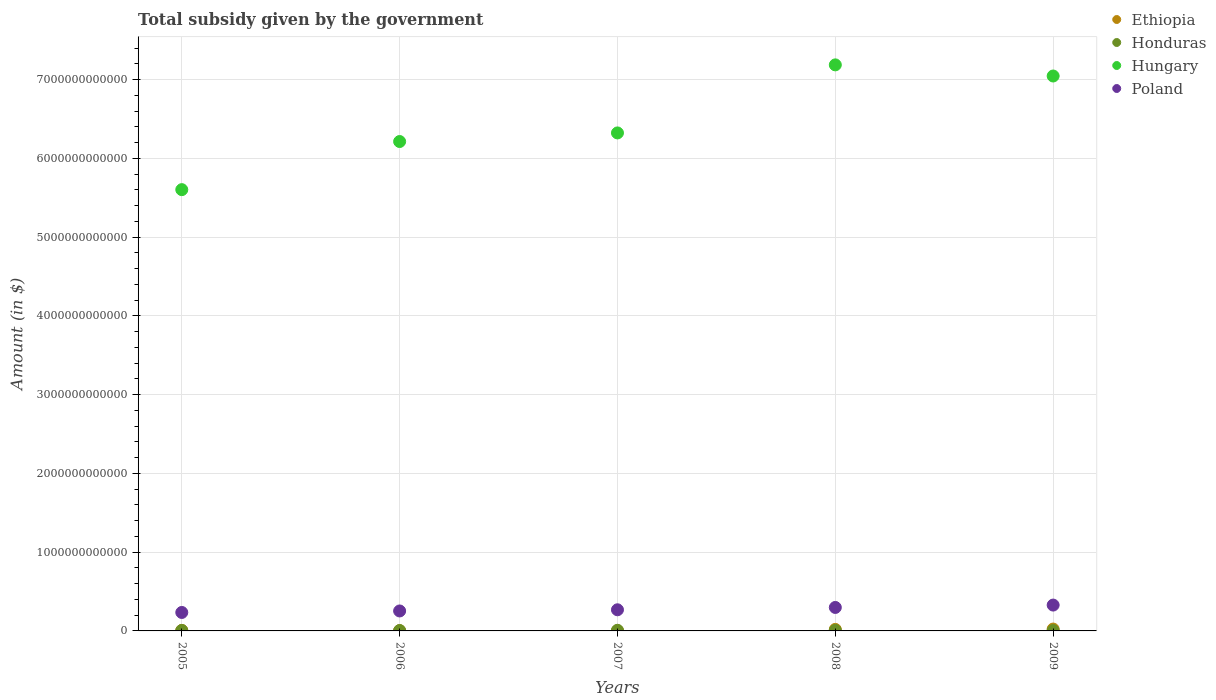How many different coloured dotlines are there?
Offer a very short reply. 4. What is the total revenue collected by the government in Hungary in 2007?
Ensure brevity in your answer.  6.32e+12. Across all years, what is the maximum total revenue collected by the government in Ethiopia?
Ensure brevity in your answer.  2.37e+1. Across all years, what is the minimum total revenue collected by the government in Ethiopia?
Offer a terse response. 1.15e+09. In which year was the total revenue collected by the government in Poland maximum?
Offer a terse response. 2009. What is the total total revenue collected by the government in Honduras in the graph?
Your answer should be compact. 3.04e+1. What is the difference between the total revenue collected by the government in Honduras in 2005 and that in 2009?
Keep it short and to the point. 5.14e+08. What is the difference between the total revenue collected by the government in Ethiopia in 2005 and the total revenue collected by the government in Poland in 2007?
Your response must be concise. -2.62e+11. What is the average total revenue collected by the government in Honduras per year?
Provide a short and direct response. 6.07e+09. In the year 2005, what is the difference between the total revenue collected by the government in Hungary and total revenue collected by the government in Poland?
Your answer should be very brief. 5.37e+12. What is the ratio of the total revenue collected by the government in Poland in 2006 to that in 2009?
Keep it short and to the point. 0.77. What is the difference between the highest and the second highest total revenue collected by the government in Honduras?
Keep it short and to the point. 7.53e+08. What is the difference between the highest and the lowest total revenue collected by the government in Ethiopia?
Provide a short and direct response. 2.26e+1. In how many years, is the total revenue collected by the government in Ethiopia greater than the average total revenue collected by the government in Ethiopia taken over all years?
Give a very brief answer. 2. Does the total revenue collected by the government in Poland monotonically increase over the years?
Ensure brevity in your answer.  Yes. Is the total revenue collected by the government in Poland strictly less than the total revenue collected by the government in Hungary over the years?
Keep it short and to the point. Yes. What is the difference between two consecutive major ticks on the Y-axis?
Offer a terse response. 1.00e+12. Are the values on the major ticks of Y-axis written in scientific E-notation?
Offer a very short reply. No. Does the graph contain any zero values?
Provide a short and direct response. No. Does the graph contain grids?
Your answer should be compact. Yes. What is the title of the graph?
Your answer should be very brief. Total subsidy given by the government. What is the label or title of the X-axis?
Provide a succinct answer. Years. What is the label or title of the Y-axis?
Offer a terse response. Amount (in $). What is the Amount (in $) in Ethiopia in 2005?
Ensure brevity in your answer.  6.65e+09. What is the Amount (in $) of Honduras in 2005?
Offer a very short reply. 5.27e+09. What is the Amount (in $) in Hungary in 2005?
Provide a succinct answer. 5.60e+12. What is the Amount (in $) in Poland in 2005?
Provide a succinct answer. 2.34e+11. What is the Amount (in $) in Ethiopia in 2006?
Make the answer very short. 3.18e+09. What is the Amount (in $) in Honduras in 2006?
Provide a succinct answer. 4.83e+09. What is the Amount (in $) in Hungary in 2006?
Offer a terse response. 6.21e+12. What is the Amount (in $) of Poland in 2006?
Make the answer very short. 2.53e+11. What is the Amount (in $) of Ethiopia in 2007?
Provide a succinct answer. 1.15e+09. What is the Amount (in $) in Honduras in 2007?
Your answer should be compact. 8.13e+09. What is the Amount (in $) in Hungary in 2007?
Keep it short and to the point. 6.32e+12. What is the Amount (in $) in Poland in 2007?
Ensure brevity in your answer.  2.68e+11. What is the Amount (in $) of Ethiopia in 2008?
Provide a short and direct response. 1.94e+1. What is the Amount (in $) of Honduras in 2008?
Your answer should be very brief. 7.38e+09. What is the Amount (in $) of Hungary in 2008?
Make the answer very short. 7.19e+12. What is the Amount (in $) in Poland in 2008?
Make the answer very short. 2.98e+11. What is the Amount (in $) in Ethiopia in 2009?
Your response must be concise. 2.37e+1. What is the Amount (in $) of Honduras in 2009?
Make the answer very short. 4.75e+09. What is the Amount (in $) in Hungary in 2009?
Make the answer very short. 7.04e+12. What is the Amount (in $) of Poland in 2009?
Your response must be concise. 3.28e+11. Across all years, what is the maximum Amount (in $) in Ethiopia?
Your answer should be compact. 2.37e+1. Across all years, what is the maximum Amount (in $) of Honduras?
Offer a very short reply. 8.13e+09. Across all years, what is the maximum Amount (in $) of Hungary?
Provide a succinct answer. 7.19e+12. Across all years, what is the maximum Amount (in $) in Poland?
Your answer should be compact. 3.28e+11. Across all years, what is the minimum Amount (in $) in Ethiopia?
Offer a very short reply. 1.15e+09. Across all years, what is the minimum Amount (in $) in Honduras?
Make the answer very short. 4.75e+09. Across all years, what is the minimum Amount (in $) in Hungary?
Keep it short and to the point. 5.60e+12. Across all years, what is the minimum Amount (in $) in Poland?
Provide a succinct answer. 2.34e+11. What is the total Amount (in $) in Ethiopia in the graph?
Your answer should be compact. 5.41e+1. What is the total Amount (in $) of Honduras in the graph?
Keep it short and to the point. 3.04e+1. What is the total Amount (in $) in Hungary in the graph?
Your answer should be very brief. 3.24e+13. What is the total Amount (in $) in Poland in the graph?
Your answer should be compact. 1.38e+12. What is the difference between the Amount (in $) in Ethiopia in 2005 and that in 2006?
Offer a terse response. 3.48e+09. What is the difference between the Amount (in $) of Honduras in 2005 and that in 2006?
Offer a terse response. 4.33e+08. What is the difference between the Amount (in $) in Hungary in 2005 and that in 2006?
Your answer should be very brief. -6.11e+11. What is the difference between the Amount (in $) in Poland in 2005 and that in 2006?
Your answer should be compact. -1.90e+1. What is the difference between the Amount (in $) in Ethiopia in 2005 and that in 2007?
Keep it short and to the point. 5.51e+09. What is the difference between the Amount (in $) of Honduras in 2005 and that in 2007?
Your answer should be compact. -2.87e+09. What is the difference between the Amount (in $) in Hungary in 2005 and that in 2007?
Provide a short and direct response. -7.20e+11. What is the difference between the Amount (in $) of Poland in 2005 and that in 2007?
Your response must be concise. -3.40e+1. What is the difference between the Amount (in $) in Ethiopia in 2005 and that in 2008?
Your response must be concise. -1.27e+1. What is the difference between the Amount (in $) in Honduras in 2005 and that in 2008?
Ensure brevity in your answer.  -2.11e+09. What is the difference between the Amount (in $) in Hungary in 2005 and that in 2008?
Your response must be concise. -1.58e+12. What is the difference between the Amount (in $) of Poland in 2005 and that in 2008?
Keep it short and to the point. -6.36e+1. What is the difference between the Amount (in $) of Ethiopia in 2005 and that in 2009?
Offer a very short reply. -1.71e+1. What is the difference between the Amount (in $) of Honduras in 2005 and that in 2009?
Your answer should be compact. 5.14e+08. What is the difference between the Amount (in $) of Hungary in 2005 and that in 2009?
Give a very brief answer. -1.44e+12. What is the difference between the Amount (in $) in Poland in 2005 and that in 2009?
Your answer should be compact. -9.38e+1. What is the difference between the Amount (in $) in Ethiopia in 2006 and that in 2007?
Your response must be concise. 2.03e+09. What is the difference between the Amount (in $) of Honduras in 2006 and that in 2007?
Give a very brief answer. -3.30e+09. What is the difference between the Amount (in $) of Hungary in 2006 and that in 2007?
Ensure brevity in your answer.  -1.09e+11. What is the difference between the Amount (in $) in Poland in 2006 and that in 2007?
Give a very brief answer. -1.49e+1. What is the difference between the Amount (in $) of Ethiopia in 2006 and that in 2008?
Make the answer very short. -1.62e+1. What is the difference between the Amount (in $) of Honduras in 2006 and that in 2008?
Offer a very short reply. -2.55e+09. What is the difference between the Amount (in $) of Hungary in 2006 and that in 2008?
Keep it short and to the point. -9.73e+11. What is the difference between the Amount (in $) of Poland in 2006 and that in 2008?
Offer a terse response. -4.45e+1. What is the difference between the Amount (in $) in Ethiopia in 2006 and that in 2009?
Offer a very short reply. -2.05e+1. What is the difference between the Amount (in $) of Honduras in 2006 and that in 2009?
Offer a very short reply. 8.13e+07. What is the difference between the Amount (in $) of Hungary in 2006 and that in 2009?
Provide a short and direct response. -8.32e+11. What is the difference between the Amount (in $) in Poland in 2006 and that in 2009?
Your answer should be very brief. -7.47e+1. What is the difference between the Amount (in $) in Ethiopia in 2007 and that in 2008?
Provide a succinct answer. -1.82e+1. What is the difference between the Amount (in $) of Honduras in 2007 and that in 2008?
Your answer should be compact. 7.53e+08. What is the difference between the Amount (in $) of Hungary in 2007 and that in 2008?
Your response must be concise. -8.64e+11. What is the difference between the Amount (in $) in Poland in 2007 and that in 2008?
Your answer should be very brief. -2.96e+1. What is the difference between the Amount (in $) of Ethiopia in 2007 and that in 2009?
Make the answer very short. -2.26e+1. What is the difference between the Amount (in $) in Honduras in 2007 and that in 2009?
Keep it short and to the point. 3.38e+09. What is the difference between the Amount (in $) in Hungary in 2007 and that in 2009?
Your answer should be very brief. -7.23e+11. What is the difference between the Amount (in $) in Poland in 2007 and that in 2009?
Offer a very short reply. -5.98e+1. What is the difference between the Amount (in $) in Ethiopia in 2008 and that in 2009?
Offer a very short reply. -4.33e+09. What is the difference between the Amount (in $) in Honduras in 2008 and that in 2009?
Provide a succinct answer. 2.63e+09. What is the difference between the Amount (in $) in Hungary in 2008 and that in 2009?
Your response must be concise. 1.41e+11. What is the difference between the Amount (in $) in Poland in 2008 and that in 2009?
Offer a terse response. -3.02e+1. What is the difference between the Amount (in $) of Ethiopia in 2005 and the Amount (in $) of Honduras in 2006?
Your response must be concise. 1.82e+09. What is the difference between the Amount (in $) in Ethiopia in 2005 and the Amount (in $) in Hungary in 2006?
Ensure brevity in your answer.  -6.21e+12. What is the difference between the Amount (in $) of Ethiopia in 2005 and the Amount (in $) of Poland in 2006?
Provide a short and direct response. -2.47e+11. What is the difference between the Amount (in $) of Honduras in 2005 and the Amount (in $) of Hungary in 2006?
Offer a terse response. -6.21e+12. What is the difference between the Amount (in $) of Honduras in 2005 and the Amount (in $) of Poland in 2006?
Keep it short and to the point. -2.48e+11. What is the difference between the Amount (in $) of Hungary in 2005 and the Amount (in $) of Poland in 2006?
Your answer should be very brief. 5.35e+12. What is the difference between the Amount (in $) of Ethiopia in 2005 and the Amount (in $) of Honduras in 2007?
Offer a terse response. -1.48e+09. What is the difference between the Amount (in $) in Ethiopia in 2005 and the Amount (in $) in Hungary in 2007?
Offer a very short reply. -6.32e+12. What is the difference between the Amount (in $) of Ethiopia in 2005 and the Amount (in $) of Poland in 2007?
Keep it short and to the point. -2.62e+11. What is the difference between the Amount (in $) of Honduras in 2005 and the Amount (in $) of Hungary in 2007?
Make the answer very short. -6.32e+12. What is the difference between the Amount (in $) of Honduras in 2005 and the Amount (in $) of Poland in 2007?
Ensure brevity in your answer.  -2.63e+11. What is the difference between the Amount (in $) of Hungary in 2005 and the Amount (in $) of Poland in 2007?
Your answer should be compact. 5.33e+12. What is the difference between the Amount (in $) in Ethiopia in 2005 and the Amount (in $) in Honduras in 2008?
Give a very brief answer. -7.26e+08. What is the difference between the Amount (in $) in Ethiopia in 2005 and the Amount (in $) in Hungary in 2008?
Ensure brevity in your answer.  -7.18e+12. What is the difference between the Amount (in $) in Ethiopia in 2005 and the Amount (in $) in Poland in 2008?
Your answer should be compact. -2.91e+11. What is the difference between the Amount (in $) in Honduras in 2005 and the Amount (in $) in Hungary in 2008?
Your response must be concise. -7.18e+12. What is the difference between the Amount (in $) in Honduras in 2005 and the Amount (in $) in Poland in 2008?
Give a very brief answer. -2.93e+11. What is the difference between the Amount (in $) of Hungary in 2005 and the Amount (in $) of Poland in 2008?
Give a very brief answer. 5.30e+12. What is the difference between the Amount (in $) in Ethiopia in 2005 and the Amount (in $) in Honduras in 2009?
Make the answer very short. 1.90e+09. What is the difference between the Amount (in $) of Ethiopia in 2005 and the Amount (in $) of Hungary in 2009?
Make the answer very short. -7.04e+12. What is the difference between the Amount (in $) in Ethiopia in 2005 and the Amount (in $) in Poland in 2009?
Keep it short and to the point. -3.21e+11. What is the difference between the Amount (in $) in Honduras in 2005 and the Amount (in $) in Hungary in 2009?
Ensure brevity in your answer.  -7.04e+12. What is the difference between the Amount (in $) in Honduras in 2005 and the Amount (in $) in Poland in 2009?
Ensure brevity in your answer.  -3.23e+11. What is the difference between the Amount (in $) in Hungary in 2005 and the Amount (in $) in Poland in 2009?
Your answer should be very brief. 5.27e+12. What is the difference between the Amount (in $) of Ethiopia in 2006 and the Amount (in $) of Honduras in 2007?
Ensure brevity in your answer.  -4.96e+09. What is the difference between the Amount (in $) of Ethiopia in 2006 and the Amount (in $) of Hungary in 2007?
Offer a terse response. -6.32e+12. What is the difference between the Amount (in $) in Ethiopia in 2006 and the Amount (in $) in Poland in 2007?
Make the answer very short. -2.65e+11. What is the difference between the Amount (in $) in Honduras in 2006 and the Amount (in $) in Hungary in 2007?
Provide a short and direct response. -6.32e+12. What is the difference between the Amount (in $) of Honduras in 2006 and the Amount (in $) of Poland in 2007?
Give a very brief answer. -2.64e+11. What is the difference between the Amount (in $) of Hungary in 2006 and the Amount (in $) of Poland in 2007?
Your response must be concise. 5.94e+12. What is the difference between the Amount (in $) of Ethiopia in 2006 and the Amount (in $) of Honduras in 2008?
Your answer should be very brief. -4.20e+09. What is the difference between the Amount (in $) in Ethiopia in 2006 and the Amount (in $) in Hungary in 2008?
Give a very brief answer. -7.18e+12. What is the difference between the Amount (in $) in Ethiopia in 2006 and the Amount (in $) in Poland in 2008?
Provide a short and direct response. -2.95e+11. What is the difference between the Amount (in $) in Honduras in 2006 and the Amount (in $) in Hungary in 2008?
Offer a terse response. -7.18e+12. What is the difference between the Amount (in $) in Honduras in 2006 and the Amount (in $) in Poland in 2008?
Offer a terse response. -2.93e+11. What is the difference between the Amount (in $) of Hungary in 2006 and the Amount (in $) of Poland in 2008?
Offer a very short reply. 5.91e+12. What is the difference between the Amount (in $) in Ethiopia in 2006 and the Amount (in $) in Honduras in 2009?
Your answer should be compact. -1.58e+09. What is the difference between the Amount (in $) of Ethiopia in 2006 and the Amount (in $) of Hungary in 2009?
Your answer should be very brief. -7.04e+12. What is the difference between the Amount (in $) of Ethiopia in 2006 and the Amount (in $) of Poland in 2009?
Offer a terse response. -3.25e+11. What is the difference between the Amount (in $) in Honduras in 2006 and the Amount (in $) in Hungary in 2009?
Your response must be concise. -7.04e+12. What is the difference between the Amount (in $) of Honduras in 2006 and the Amount (in $) of Poland in 2009?
Provide a succinct answer. -3.23e+11. What is the difference between the Amount (in $) in Hungary in 2006 and the Amount (in $) in Poland in 2009?
Provide a short and direct response. 5.88e+12. What is the difference between the Amount (in $) of Ethiopia in 2007 and the Amount (in $) of Honduras in 2008?
Make the answer very short. -6.23e+09. What is the difference between the Amount (in $) of Ethiopia in 2007 and the Amount (in $) of Hungary in 2008?
Your answer should be compact. -7.18e+12. What is the difference between the Amount (in $) of Ethiopia in 2007 and the Amount (in $) of Poland in 2008?
Ensure brevity in your answer.  -2.97e+11. What is the difference between the Amount (in $) in Honduras in 2007 and the Amount (in $) in Hungary in 2008?
Ensure brevity in your answer.  -7.18e+12. What is the difference between the Amount (in $) in Honduras in 2007 and the Amount (in $) in Poland in 2008?
Your answer should be very brief. -2.90e+11. What is the difference between the Amount (in $) of Hungary in 2007 and the Amount (in $) of Poland in 2008?
Provide a succinct answer. 6.02e+12. What is the difference between the Amount (in $) in Ethiopia in 2007 and the Amount (in $) in Honduras in 2009?
Provide a short and direct response. -3.61e+09. What is the difference between the Amount (in $) of Ethiopia in 2007 and the Amount (in $) of Hungary in 2009?
Offer a terse response. -7.04e+12. What is the difference between the Amount (in $) in Ethiopia in 2007 and the Amount (in $) in Poland in 2009?
Provide a succinct answer. -3.27e+11. What is the difference between the Amount (in $) of Honduras in 2007 and the Amount (in $) of Hungary in 2009?
Your answer should be very brief. -7.04e+12. What is the difference between the Amount (in $) of Honduras in 2007 and the Amount (in $) of Poland in 2009?
Keep it short and to the point. -3.20e+11. What is the difference between the Amount (in $) in Hungary in 2007 and the Amount (in $) in Poland in 2009?
Your answer should be very brief. 5.99e+12. What is the difference between the Amount (in $) in Ethiopia in 2008 and the Amount (in $) in Honduras in 2009?
Ensure brevity in your answer.  1.46e+1. What is the difference between the Amount (in $) of Ethiopia in 2008 and the Amount (in $) of Hungary in 2009?
Your response must be concise. -7.03e+12. What is the difference between the Amount (in $) in Ethiopia in 2008 and the Amount (in $) in Poland in 2009?
Your answer should be compact. -3.09e+11. What is the difference between the Amount (in $) of Honduras in 2008 and the Amount (in $) of Hungary in 2009?
Offer a terse response. -7.04e+12. What is the difference between the Amount (in $) of Honduras in 2008 and the Amount (in $) of Poland in 2009?
Give a very brief answer. -3.21e+11. What is the difference between the Amount (in $) in Hungary in 2008 and the Amount (in $) in Poland in 2009?
Offer a terse response. 6.86e+12. What is the average Amount (in $) in Ethiopia per year?
Ensure brevity in your answer.  1.08e+1. What is the average Amount (in $) of Honduras per year?
Provide a short and direct response. 6.07e+09. What is the average Amount (in $) in Hungary per year?
Your response must be concise. 6.47e+12. What is the average Amount (in $) of Poland per year?
Ensure brevity in your answer.  2.76e+11. In the year 2005, what is the difference between the Amount (in $) of Ethiopia and Amount (in $) of Honduras?
Give a very brief answer. 1.39e+09. In the year 2005, what is the difference between the Amount (in $) in Ethiopia and Amount (in $) in Hungary?
Your answer should be compact. -5.60e+12. In the year 2005, what is the difference between the Amount (in $) of Ethiopia and Amount (in $) of Poland?
Offer a very short reply. -2.28e+11. In the year 2005, what is the difference between the Amount (in $) in Honduras and Amount (in $) in Hungary?
Offer a terse response. -5.60e+12. In the year 2005, what is the difference between the Amount (in $) in Honduras and Amount (in $) in Poland?
Give a very brief answer. -2.29e+11. In the year 2005, what is the difference between the Amount (in $) in Hungary and Amount (in $) in Poland?
Keep it short and to the point. 5.37e+12. In the year 2006, what is the difference between the Amount (in $) in Ethiopia and Amount (in $) in Honduras?
Provide a short and direct response. -1.66e+09. In the year 2006, what is the difference between the Amount (in $) of Ethiopia and Amount (in $) of Hungary?
Provide a succinct answer. -6.21e+12. In the year 2006, what is the difference between the Amount (in $) of Ethiopia and Amount (in $) of Poland?
Your response must be concise. -2.50e+11. In the year 2006, what is the difference between the Amount (in $) in Honduras and Amount (in $) in Hungary?
Provide a short and direct response. -6.21e+12. In the year 2006, what is the difference between the Amount (in $) in Honduras and Amount (in $) in Poland?
Your answer should be very brief. -2.49e+11. In the year 2006, what is the difference between the Amount (in $) of Hungary and Amount (in $) of Poland?
Your answer should be compact. 5.96e+12. In the year 2007, what is the difference between the Amount (in $) of Ethiopia and Amount (in $) of Honduras?
Offer a terse response. -6.99e+09. In the year 2007, what is the difference between the Amount (in $) in Ethiopia and Amount (in $) in Hungary?
Your response must be concise. -6.32e+12. In the year 2007, what is the difference between the Amount (in $) in Ethiopia and Amount (in $) in Poland?
Your answer should be very brief. -2.67e+11. In the year 2007, what is the difference between the Amount (in $) of Honduras and Amount (in $) of Hungary?
Your response must be concise. -6.31e+12. In the year 2007, what is the difference between the Amount (in $) in Honduras and Amount (in $) in Poland?
Offer a terse response. -2.60e+11. In the year 2007, what is the difference between the Amount (in $) in Hungary and Amount (in $) in Poland?
Ensure brevity in your answer.  6.05e+12. In the year 2008, what is the difference between the Amount (in $) in Ethiopia and Amount (in $) in Honduras?
Offer a terse response. 1.20e+1. In the year 2008, what is the difference between the Amount (in $) of Ethiopia and Amount (in $) of Hungary?
Give a very brief answer. -7.17e+12. In the year 2008, what is the difference between the Amount (in $) of Ethiopia and Amount (in $) of Poland?
Offer a terse response. -2.79e+11. In the year 2008, what is the difference between the Amount (in $) of Honduras and Amount (in $) of Hungary?
Provide a short and direct response. -7.18e+12. In the year 2008, what is the difference between the Amount (in $) in Honduras and Amount (in $) in Poland?
Offer a very short reply. -2.91e+11. In the year 2008, what is the difference between the Amount (in $) in Hungary and Amount (in $) in Poland?
Your answer should be compact. 6.89e+12. In the year 2009, what is the difference between the Amount (in $) of Ethiopia and Amount (in $) of Honduras?
Give a very brief answer. 1.90e+1. In the year 2009, what is the difference between the Amount (in $) in Ethiopia and Amount (in $) in Hungary?
Your answer should be very brief. -7.02e+12. In the year 2009, what is the difference between the Amount (in $) in Ethiopia and Amount (in $) in Poland?
Give a very brief answer. -3.04e+11. In the year 2009, what is the difference between the Amount (in $) of Honduras and Amount (in $) of Hungary?
Your response must be concise. -7.04e+12. In the year 2009, what is the difference between the Amount (in $) of Honduras and Amount (in $) of Poland?
Your answer should be very brief. -3.23e+11. In the year 2009, what is the difference between the Amount (in $) in Hungary and Amount (in $) in Poland?
Your response must be concise. 6.72e+12. What is the ratio of the Amount (in $) of Ethiopia in 2005 to that in 2006?
Your answer should be very brief. 2.09. What is the ratio of the Amount (in $) in Honduras in 2005 to that in 2006?
Offer a very short reply. 1.09. What is the ratio of the Amount (in $) in Hungary in 2005 to that in 2006?
Provide a succinct answer. 0.9. What is the ratio of the Amount (in $) of Poland in 2005 to that in 2006?
Provide a short and direct response. 0.92. What is the ratio of the Amount (in $) of Ethiopia in 2005 to that in 2007?
Your response must be concise. 5.8. What is the ratio of the Amount (in $) in Honduras in 2005 to that in 2007?
Give a very brief answer. 0.65. What is the ratio of the Amount (in $) in Hungary in 2005 to that in 2007?
Keep it short and to the point. 0.89. What is the ratio of the Amount (in $) in Poland in 2005 to that in 2007?
Provide a succinct answer. 0.87. What is the ratio of the Amount (in $) in Ethiopia in 2005 to that in 2008?
Give a very brief answer. 0.34. What is the ratio of the Amount (in $) in Honduras in 2005 to that in 2008?
Provide a succinct answer. 0.71. What is the ratio of the Amount (in $) in Hungary in 2005 to that in 2008?
Give a very brief answer. 0.78. What is the ratio of the Amount (in $) of Poland in 2005 to that in 2008?
Offer a very short reply. 0.79. What is the ratio of the Amount (in $) in Ethiopia in 2005 to that in 2009?
Your answer should be compact. 0.28. What is the ratio of the Amount (in $) of Honduras in 2005 to that in 2009?
Your response must be concise. 1.11. What is the ratio of the Amount (in $) in Hungary in 2005 to that in 2009?
Ensure brevity in your answer.  0.8. What is the ratio of the Amount (in $) of Poland in 2005 to that in 2009?
Offer a very short reply. 0.71. What is the ratio of the Amount (in $) in Ethiopia in 2006 to that in 2007?
Ensure brevity in your answer.  2.77. What is the ratio of the Amount (in $) of Honduras in 2006 to that in 2007?
Provide a succinct answer. 0.59. What is the ratio of the Amount (in $) of Hungary in 2006 to that in 2007?
Give a very brief answer. 0.98. What is the ratio of the Amount (in $) of Poland in 2006 to that in 2007?
Your response must be concise. 0.94. What is the ratio of the Amount (in $) of Ethiopia in 2006 to that in 2008?
Offer a very short reply. 0.16. What is the ratio of the Amount (in $) of Honduras in 2006 to that in 2008?
Offer a very short reply. 0.66. What is the ratio of the Amount (in $) in Hungary in 2006 to that in 2008?
Ensure brevity in your answer.  0.86. What is the ratio of the Amount (in $) in Poland in 2006 to that in 2008?
Your response must be concise. 0.85. What is the ratio of the Amount (in $) in Ethiopia in 2006 to that in 2009?
Make the answer very short. 0.13. What is the ratio of the Amount (in $) of Honduras in 2006 to that in 2009?
Your answer should be very brief. 1.02. What is the ratio of the Amount (in $) in Hungary in 2006 to that in 2009?
Provide a short and direct response. 0.88. What is the ratio of the Amount (in $) in Poland in 2006 to that in 2009?
Your response must be concise. 0.77. What is the ratio of the Amount (in $) in Ethiopia in 2007 to that in 2008?
Your answer should be compact. 0.06. What is the ratio of the Amount (in $) of Honduras in 2007 to that in 2008?
Ensure brevity in your answer.  1.1. What is the ratio of the Amount (in $) in Hungary in 2007 to that in 2008?
Your answer should be compact. 0.88. What is the ratio of the Amount (in $) in Poland in 2007 to that in 2008?
Offer a terse response. 0.9. What is the ratio of the Amount (in $) of Ethiopia in 2007 to that in 2009?
Offer a very short reply. 0.05. What is the ratio of the Amount (in $) of Honduras in 2007 to that in 2009?
Provide a succinct answer. 1.71. What is the ratio of the Amount (in $) in Hungary in 2007 to that in 2009?
Your answer should be very brief. 0.9. What is the ratio of the Amount (in $) in Poland in 2007 to that in 2009?
Your response must be concise. 0.82. What is the ratio of the Amount (in $) of Ethiopia in 2008 to that in 2009?
Your answer should be very brief. 0.82. What is the ratio of the Amount (in $) of Honduras in 2008 to that in 2009?
Provide a short and direct response. 1.55. What is the ratio of the Amount (in $) of Hungary in 2008 to that in 2009?
Provide a succinct answer. 1.02. What is the ratio of the Amount (in $) of Poland in 2008 to that in 2009?
Provide a short and direct response. 0.91. What is the difference between the highest and the second highest Amount (in $) of Ethiopia?
Give a very brief answer. 4.33e+09. What is the difference between the highest and the second highest Amount (in $) of Honduras?
Make the answer very short. 7.53e+08. What is the difference between the highest and the second highest Amount (in $) of Hungary?
Give a very brief answer. 1.41e+11. What is the difference between the highest and the second highest Amount (in $) of Poland?
Give a very brief answer. 3.02e+1. What is the difference between the highest and the lowest Amount (in $) in Ethiopia?
Your response must be concise. 2.26e+1. What is the difference between the highest and the lowest Amount (in $) of Honduras?
Make the answer very short. 3.38e+09. What is the difference between the highest and the lowest Amount (in $) in Hungary?
Keep it short and to the point. 1.58e+12. What is the difference between the highest and the lowest Amount (in $) of Poland?
Your response must be concise. 9.38e+1. 